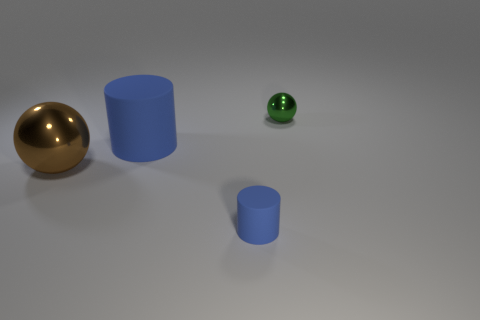What number of other cylinders are the same color as the tiny rubber cylinder? 1 